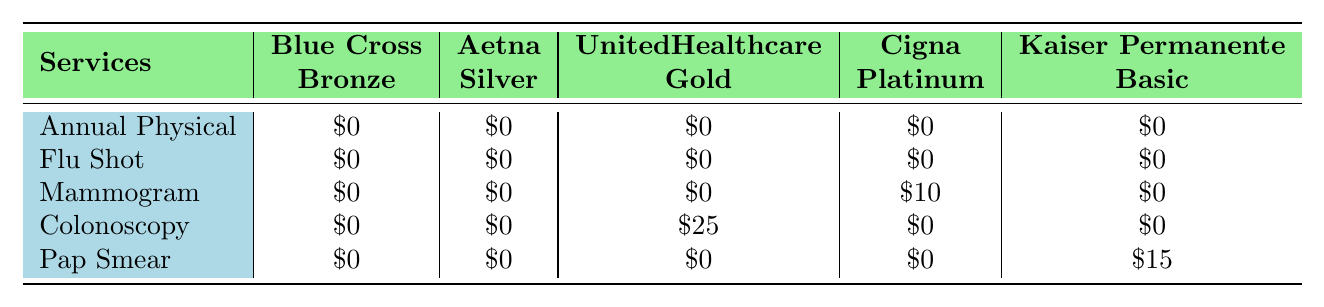What is the out-of-pocket cost for an Annual Physical under the Blue Cross Bronze plan? The table shows that the cost for an Annual Physical under the Blue Cross Bronze plan is listed as $0.
Answer: $0 Which service has the highest out-of-pocket cost under the UnitedHealthcare Gold plan? Looking at the UnitedHealthcare Gold plan column, the Mammogram costs $10, and the Colonoscopy costs $25. The Colonoscopy has the highest cost.
Answer: Colonoscopy Is there any preventive care service that costs $15 under the Kaiser Permanente Basic plan? By checking the Kaiser Permanente Basic plan column, we see that the Pap Smear costs $15. Therefore, yes, there is a service that costs $15.
Answer: Yes What is the total out-of-pocket cost for a Mammogram and a Pap Smear under the Cigna Platinum plan? The Mammogram costs $10 and the Pap Smear costs $0 under the Cigna Platinum plan. Summing these together, we get $10 + $0 = $10.
Answer: $10 Under which plan is a Colonoscopy free of charge? The table indicates that the Colonoscopy has a cost of $0 under both the Blue Cross Bronze and the Kaiser Permanente Basic plans.
Answer: Blue Cross Bronze and Kaiser Permanente Basic What is the average out-of-pocket cost for a Flu Shot across all insurance plans? The Flu Shot has the same cost of $0 under all five plans. Thus, to calculate the average, we sum $0 for all plans and divide by 5. The average is $0/5 = $0.
Answer: $0 Are there any services with no out-of-pocket costs under the Aetna Silver plan? Checking the Aetna Silver plan column, we observe that all services listed have a cost of $0, indicating that all services have no out-of-pocket costs.
Answer: Yes Which two plans provide free Mammograms? The table shows that the Mammogram is $0 under Blue Cross Bronze, Aetna Silver, and Kaiser Permanente Basic. The two plans providing Mammograms at no cost are Blue Cross Bronze and Aetna Silver.
Answer: Blue Cross Bronze and Aetna Silver If a person wants to minimize costs for preventive care, which plan should they choose? By evaluating the out-of-pocket costs across all services, both Blue Cross Bronze and Aetna Silver offer $0 for all services. Therefore, these plans minimize costs for preventive care.
Answer: Blue Cross Bronze and Aetna Silver Calculate the total out-of-pocket cost for preventive services across all plans for one individual. Adding up the out-of-pocket costs for each service: 0 (Annual Physical) + 0 (Flu Shot) + 0 (Mammogram) + 0 (Colonoscopy) + 0 (Pap Smear) = $0 total for six services across all plans. Every individual incurs no out-of-pocket costs.
Answer: $0 